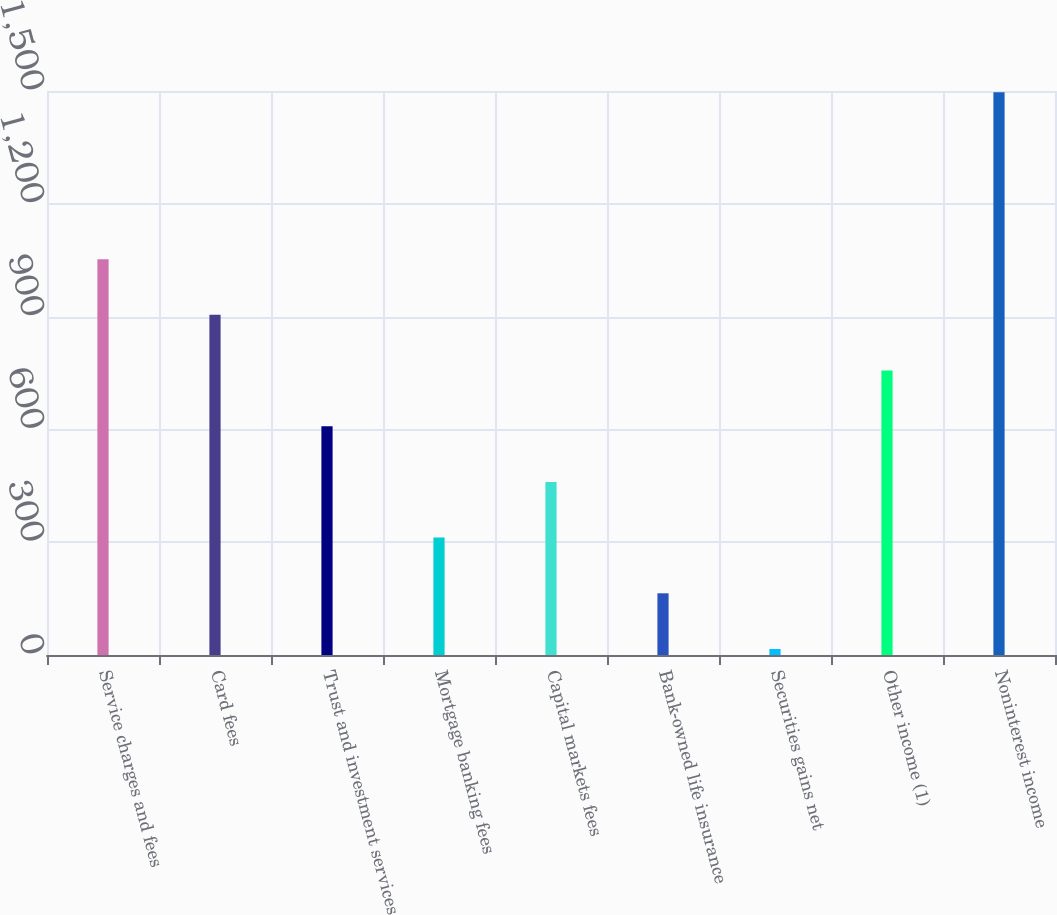Convert chart to OTSL. <chart><loc_0><loc_0><loc_500><loc_500><bar_chart><fcel>Service charges and fees<fcel>Card fees<fcel>Trust and investment services<fcel>Mortgage banking fees<fcel>Capital markets fees<fcel>Bank-owned life insurance<fcel>Securities gains net<fcel>Other income (1)<fcel>Noninterest income<nl><fcel>1052.7<fcel>904.6<fcel>608.4<fcel>312.2<fcel>460.3<fcel>164.1<fcel>16<fcel>756.5<fcel>1497<nl></chart> 